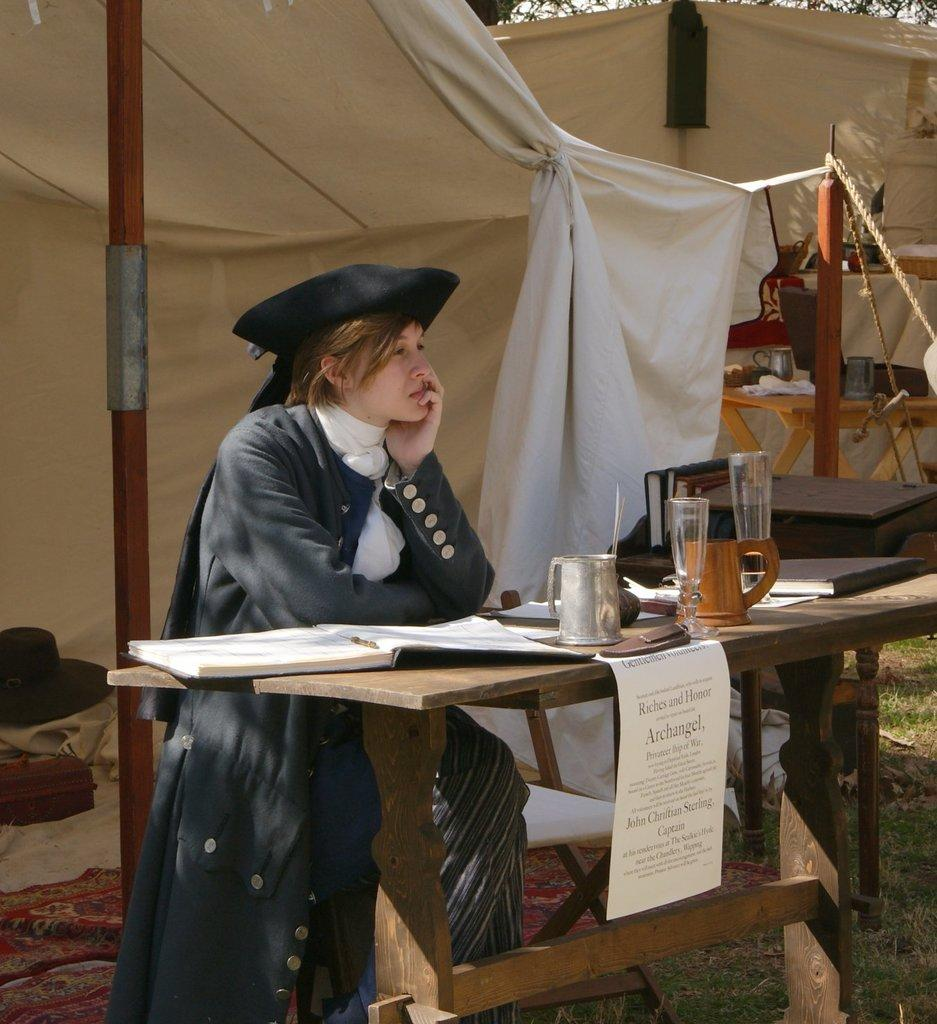What is the woman in the image doing? The woman is sitting in a chair. Where is the chair located in relation to the table? The chair is near a table. What items can be seen on the table? There is a jug, a glass, a paper, and a book on the table. What can be seen in the background of the image? There is a tent, a tree, and a hat in the background. What type of apple is being served after the event in the image? There is no apple or event present in the image. What is the woman doing on top of the tent in the image? The woman is sitting in a chair near a table, and there is no indication that she is on top of the tent. 